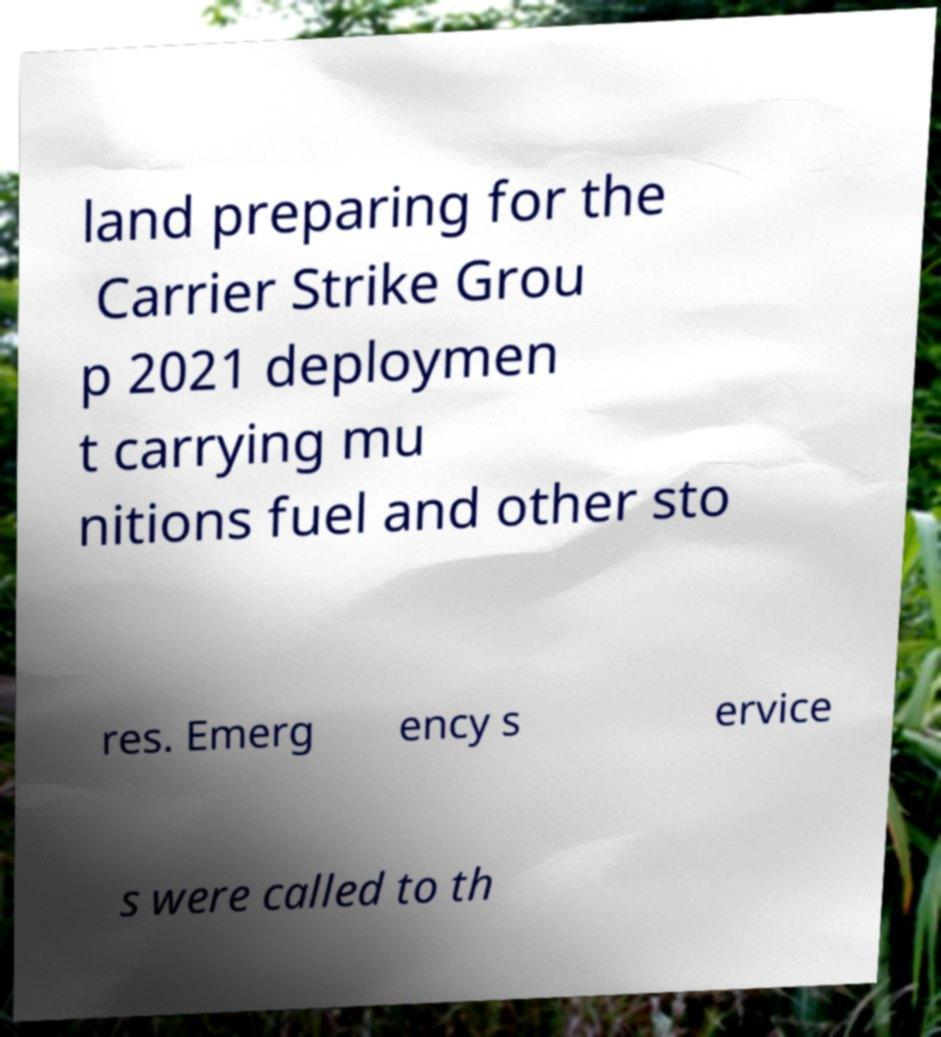What messages or text are displayed in this image? I need them in a readable, typed format. land preparing for the Carrier Strike Grou p 2021 deploymen t carrying mu nitions fuel and other sto res. Emerg ency s ervice s were called to th 